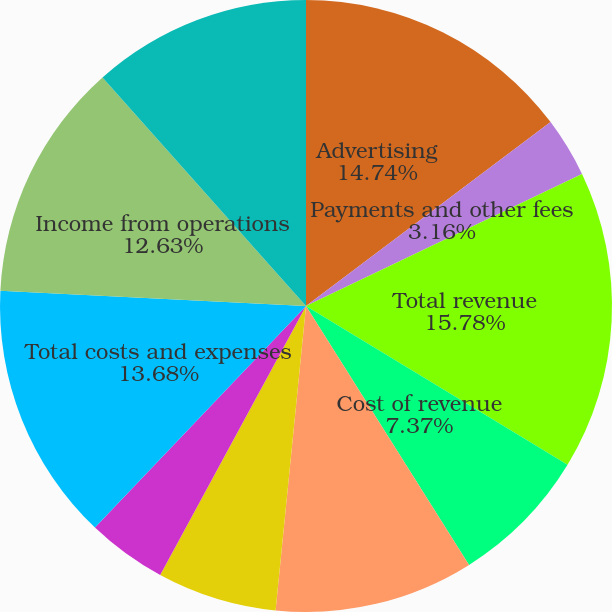Convert chart. <chart><loc_0><loc_0><loc_500><loc_500><pie_chart><fcel>Advertising<fcel>Payments and other fees<fcel>Total revenue<fcel>Cost of revenue<fcel>Research and development<fcel>Marketing and sales<fcel>General and administrative<fcel>Total costs and expenses<fcel>Income from operations<fcel>Income before provision for<nl><fcel>14.74%<fcel>3.16%<fcel>15.79%<fcel>7.37%<fcel>10.53%<fcel>6.32%<fcel>4.21%<fcel>13.68%<fcel>12.63%<fcel>11.58%<nl></chart> 